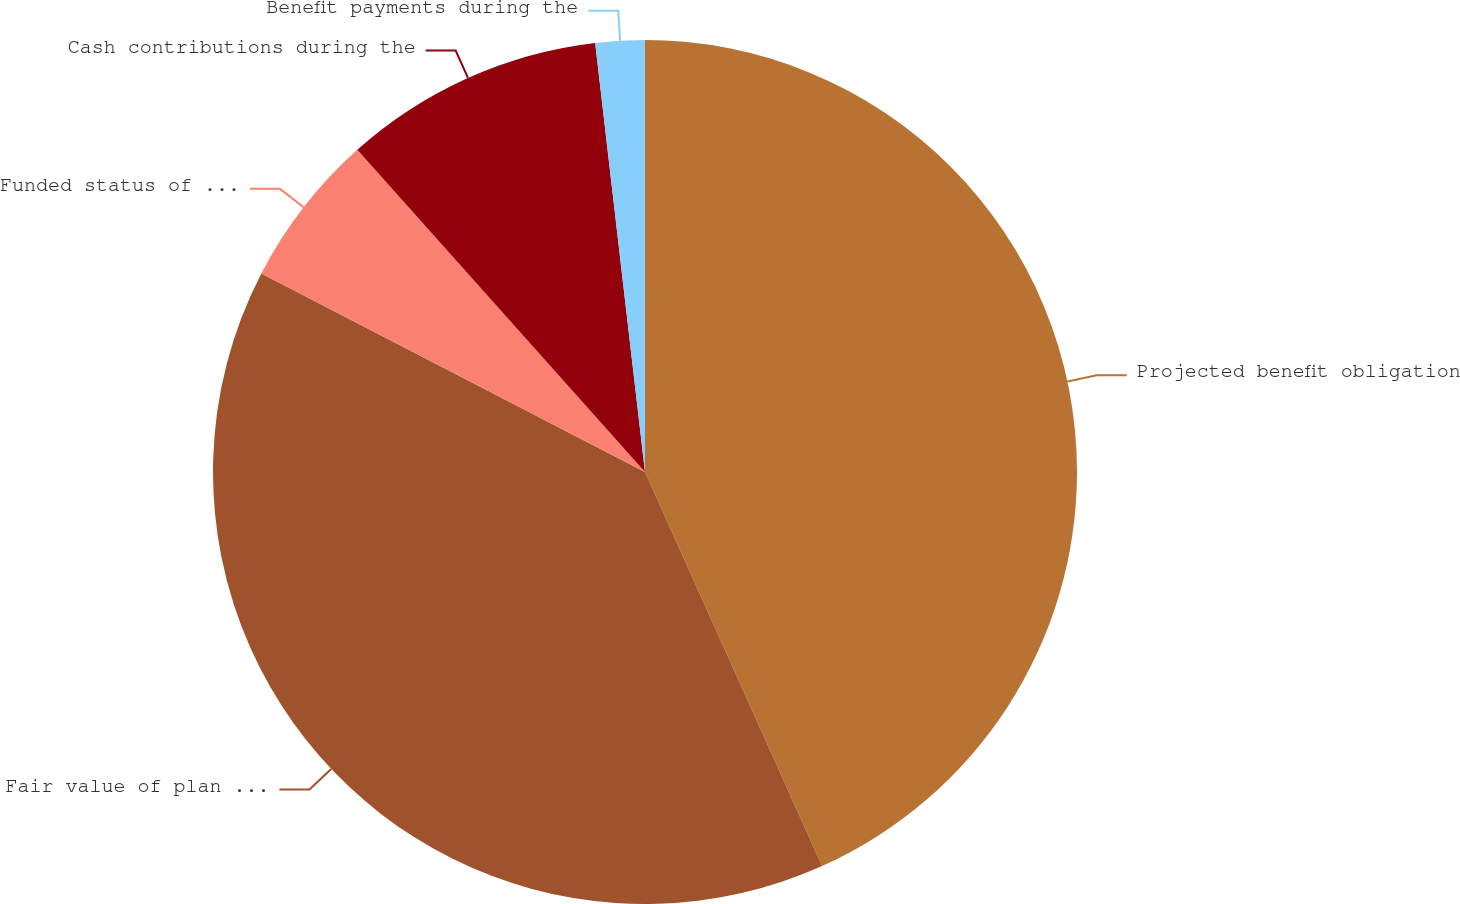Convert chart. <chart><loc_0><loc_0><loc_500><loc_500><pie_chart><fcel>Projected benefit obligation<fcel>Fair value of plan assets<fcel>Funded status of the plans<fcel>Cash contributions during the<fcel>Benefit payments during the<nl><fcel>43.28%<fcel>39.32%<fcel>5.8%<fcel>9.76%<fcel>1.84%<nl></chart> 